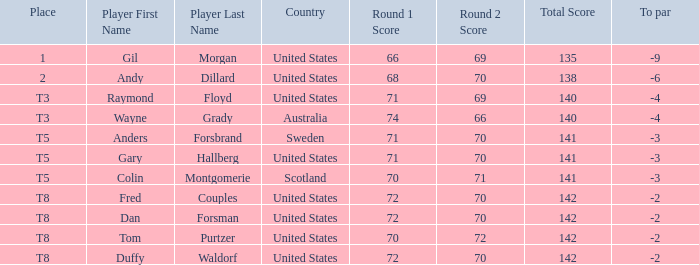What is the T8 Place Player? Fred Couples, Dan Forsman, Tom Purtzer, Duffy Waldorf. 